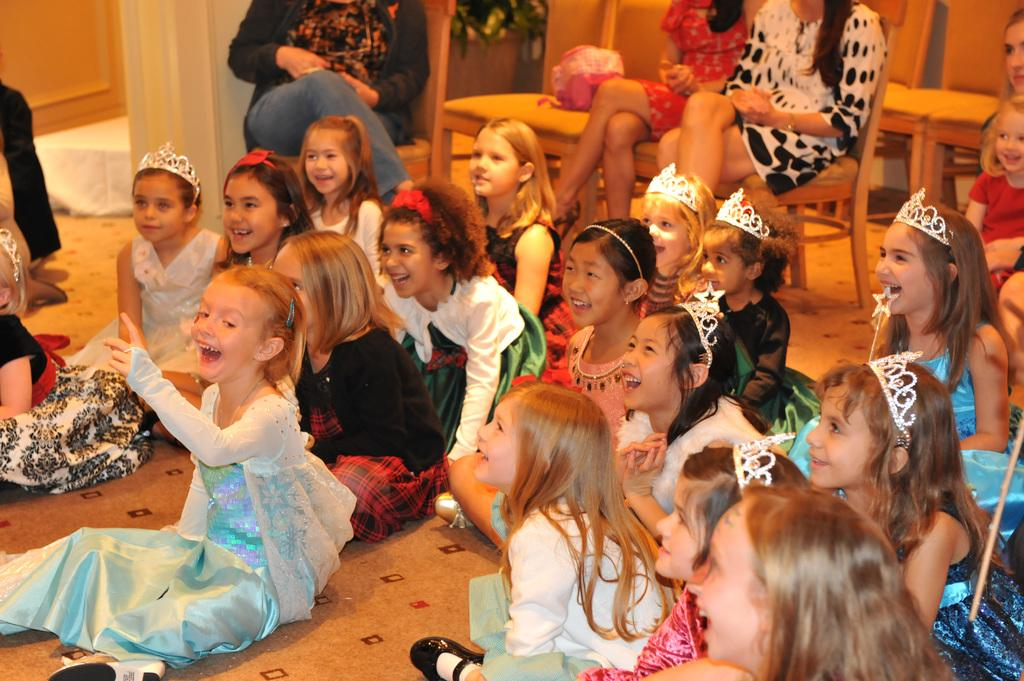What are the girls in the image doing? The girls in the image are sitting on the floor. What can be seen in the background of the image? There are chairs visible in the background of the image. What is to the left of the girls in the image? There is a wall with a pillar to the left in the image. What is visible at the bottom of the image? There is a floor visible at the bottom of the image. What type of hammer is being used by the girls in the image? There is no hammer present in the image; the girls are sitting on the floor. 